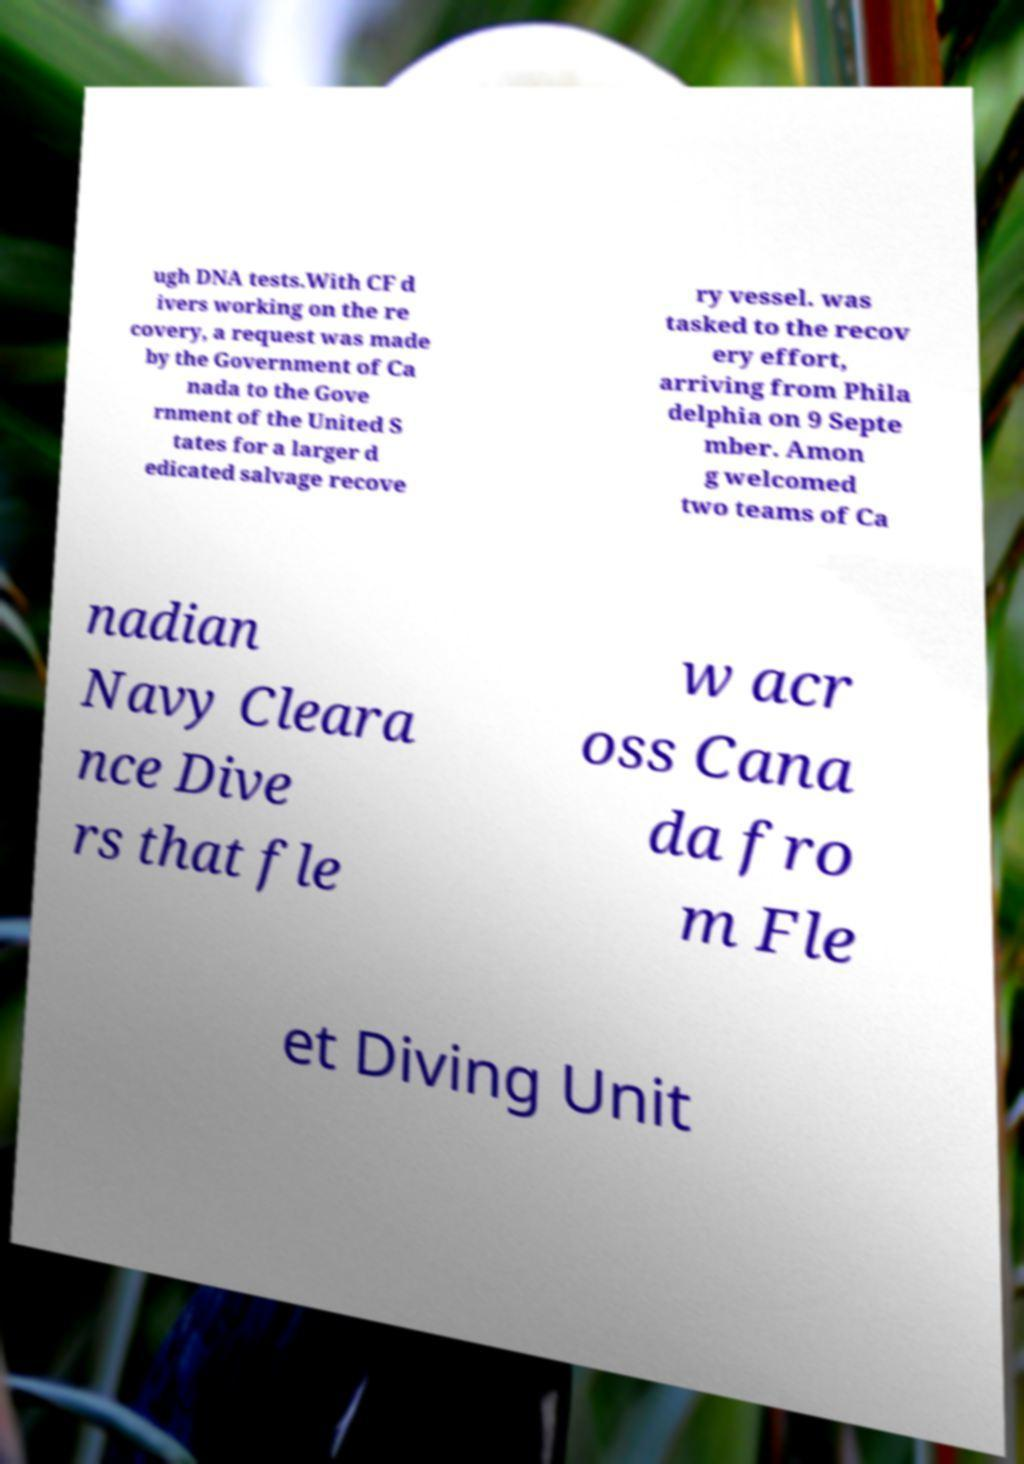Please read and relay the text visible in this image. What does it say? ugh DNA tests.With CF d ivers working on the re covery, a request was made by the Government of Ca nada to the Gove rnment of the United S tates for a larger d edicated salvage recove ry vessel. was tasked to the recov ery effort, arriving from Phila delphia on 9 Septe mber. Amon g welcomed two teams of Ca nadian Navy Cleara nce Dive rs that fle w acr oss Cana da fro m Fle et Diving Unit 